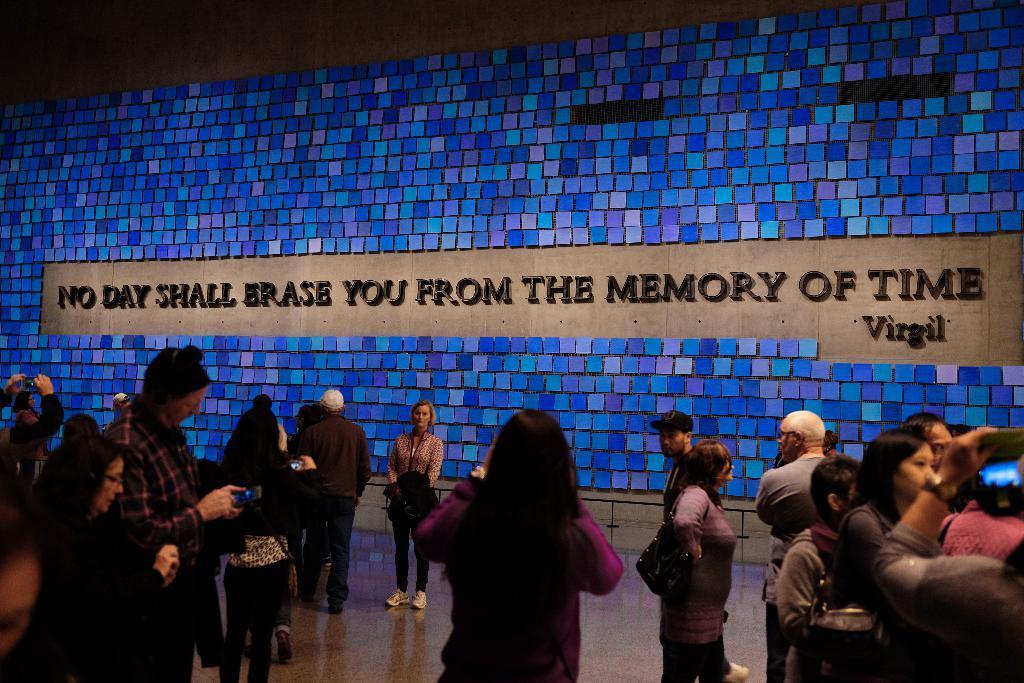Can you describe this image briefly? In this image we can see people standing on the floor and there is a name board on the wall. 